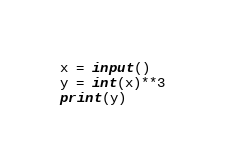Convert code to text. <code><loc_0><loc_0><loc_500><loc_500><_Python_>x = input()
y = int(x)**3
print(y)
</code> 